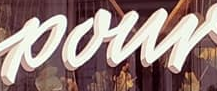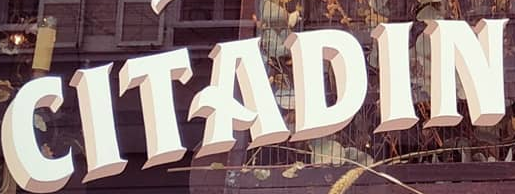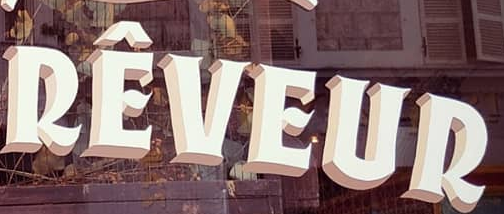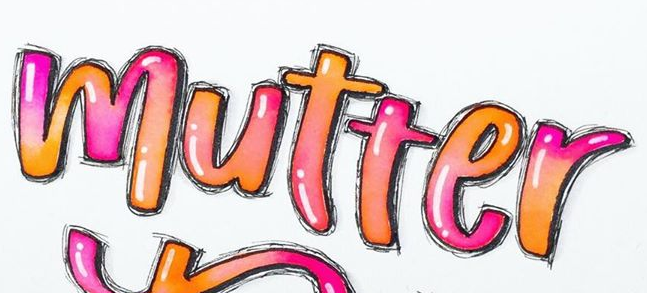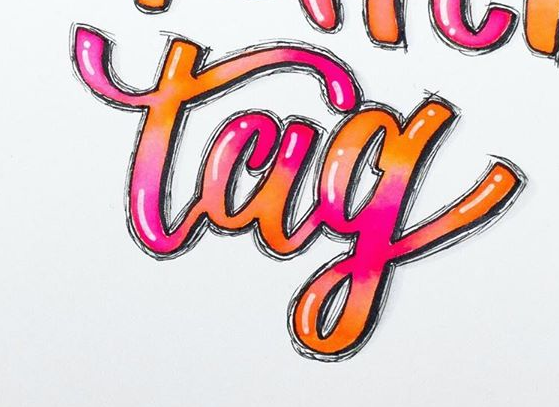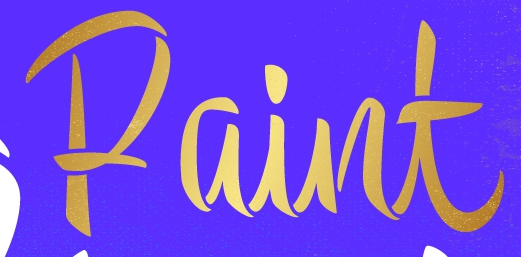Transcribe the words shown in these images in order, separated by a semicolon. pour; CITADIN; RÊVEUR; mutter; tag; Paint 